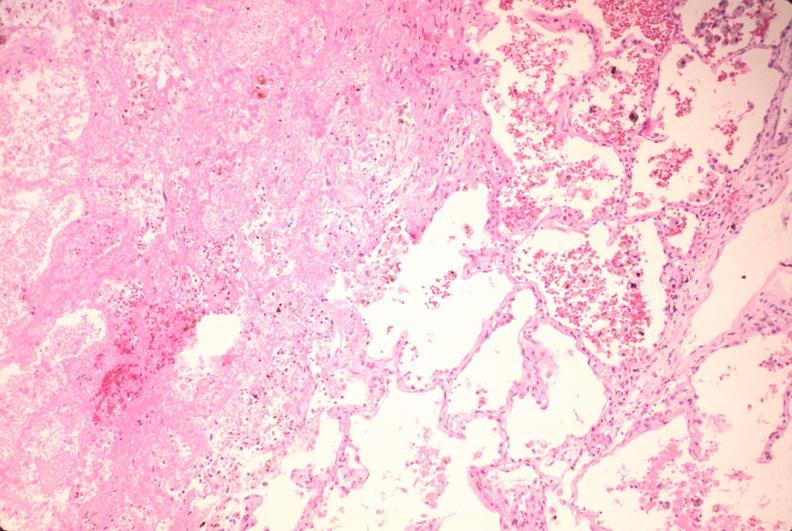does this image show lung, infarct, acute and organized?
Answer the question using a single word or phrase. Yes 